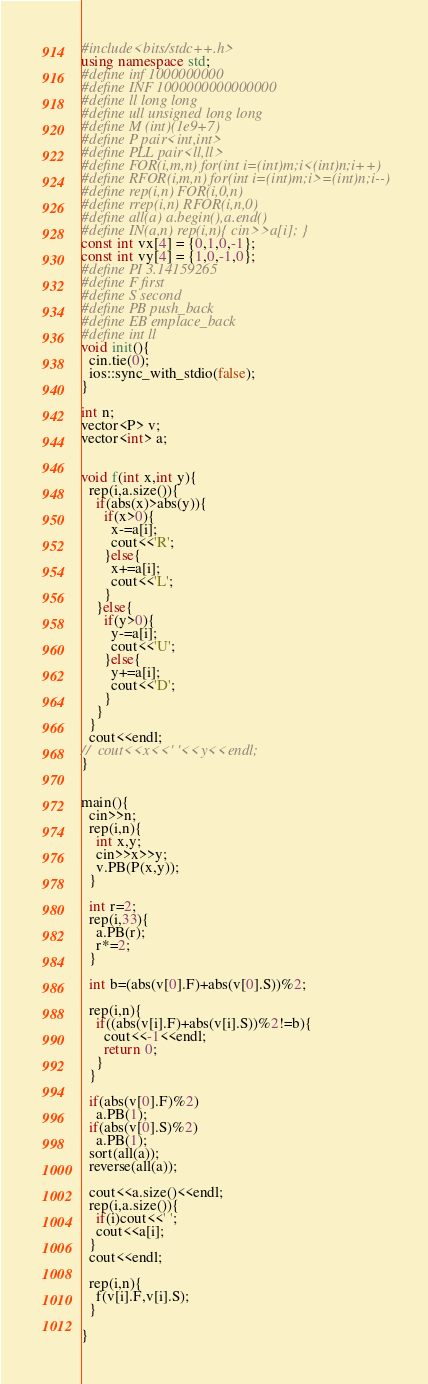<code> <loc_0><loc_0><loc_500><loc_500><_C++_>
#include<bits/stdc++.h>
using namespace std;
#define inf 1000000000
#define INF 1000000000000000
#define ll long long
#define ull unsigned long long
#define M (int)(1e9+7)
#define P pair<int,int>
#define PLL pair<ll,ll>
#define FOR(i,m,n) for(int i=(int)m;i<(int)n;i++)
#define RFOR(i,m,n) for(int i=(int)m;i>=(int)n;i--)
#define rep(i,n) FOR(i,0,n)
#define rrep(i,n) RFOR(i,n,0)
#define all(a) a.begin(),a.end()
#define IN(a,n) rep(i,n){ cin>>a[i]; }
const int vx[4] = {0,1,0,-1};
const int vy[4] = {1,0,-1,0};
#define PI 3.14159265
#define F first
#define S second
#define PB push_back
#define EB emplace_back
#define int ll
void init(){
  cin.tie(0);
  ios::sync_with_stdio(false);
}

int n;
vector<P> v;
vector<int> a;


void f(int x,int y){
  rep(i,a.size()){
    if(abs(x)>abs(y)){
      if(x>0){
        x-=a[i];
        cout<<'R';
      }else{
        x+=a[i];
        cout<<'L';
      }
    }else{
      if(y>0){
        y-=a[i];
        cout<<'U';
      }else{
        y+=a[i];
        cout<<'D';
      }
    }
  }
  cout<<endl;
//  cout<<x<<' '<<y<<endl;
}


main(){
  cin>>n;
  rep(i,n){
    int x,y;
    cin>>x>>y;
    v.PB(P(x,y));
  }

  int r=2;
  rep(i,33){
    a.PB(r);
    r*=2;
  }

  int b=(abs(v[0].F)+abs(v[0].S))%2;

  rep(i,n){
    if((abs(v[i].F)+abs(v[i].S))%2!=b){
      cout<<-1<<endl;
      return 0;
    }
  }

  if(abs(v[0].F)%2)
    a.PB(1);
  if(abs(v[0].S)%2)
    a.PB(1);
  sort(all(a));
  reverse(all(a));

  cout<<a.size()<<endl;
  rep(i,a.size()){
    if(i)cout<<' ';
    cout<<a[i];
  }
  cout<<endl;

  rep(i,n){
    f(v[i].F,v[i].S);
  }

}

</code> 